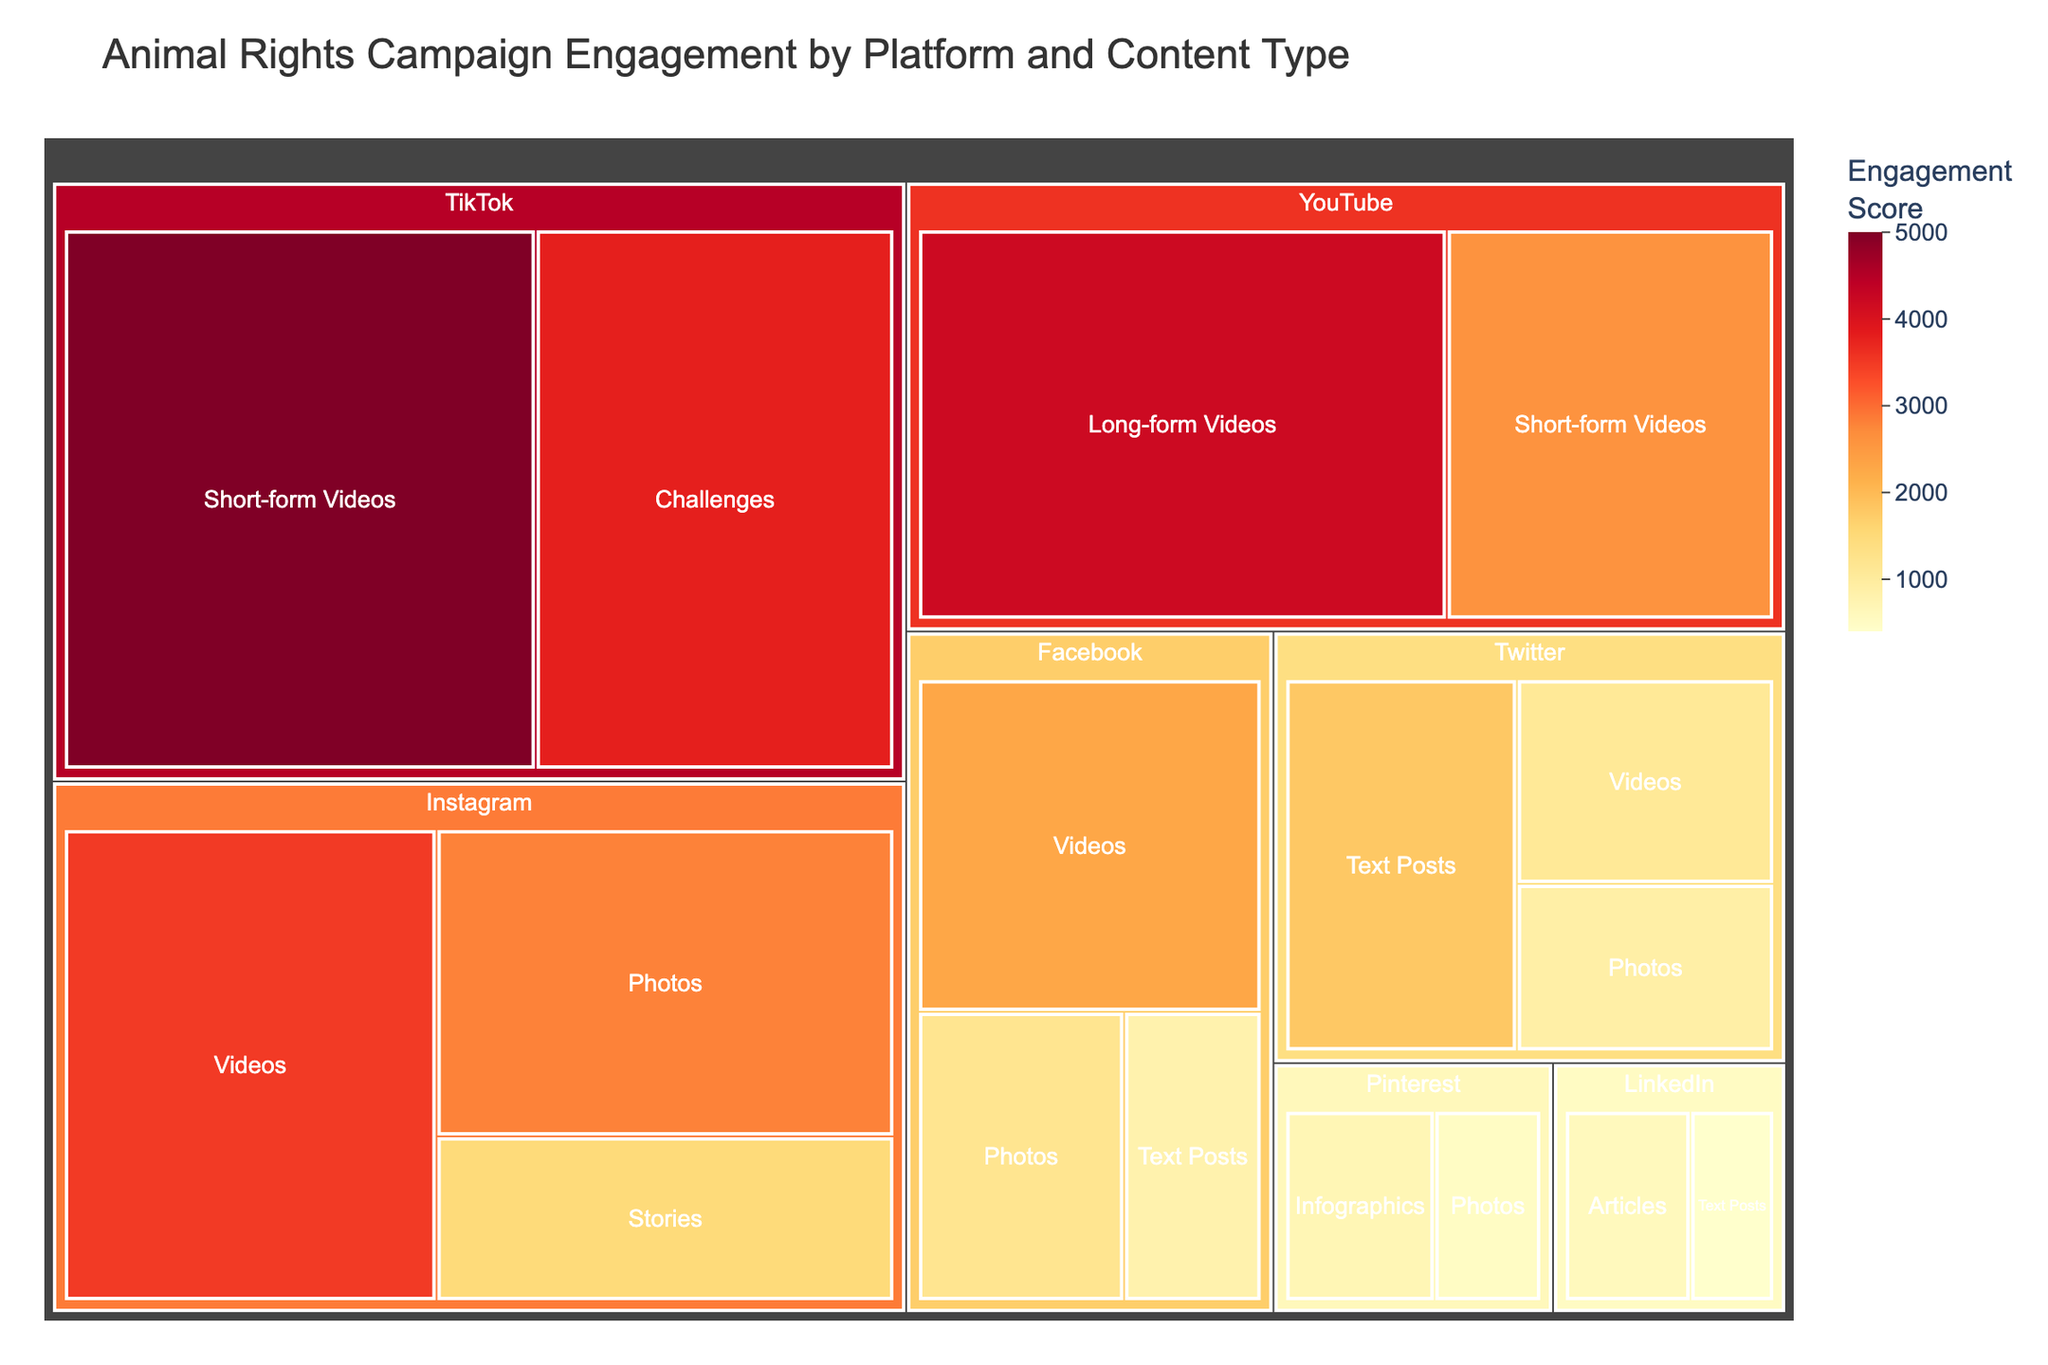What's the title of the figure? The title of the figure can be read directly at the top.
Answer: Animal Rights Campaign Engagement by Platform and Content Type Which platform has the highest engagement score? Look for the platform with the largest and darkest color block.
Answer: TikTok What's the engagement score for Instagram Stories? Find the "Instagram" section and look for the "Stories" block. The engagement score is written within it.
Answer: 1500 Compare the engagement scores between Facebook Photos and Facebook Videos. Which one has a higher score and by how much? Locate the Facebook section, then compare the scores of "Photos" and "Videos". Subtract the "Photos" score from the "Videos" score.
Answer: Facebook Videos have a higher score by 1100 What is the total engagement score for all content types on Twitter? Locate the Twitter section and sum up the scores for all listed content types (Text Posts, Photos, Videos).
Answer: 4800 Which content type has the highest engagement score on YouTube? Look for the YouTube section and compare the engagement scores of the listed content types (Long-form Videos, Short-form Videos).
Answer: Long-form Videos What is the difference in engagement score between TikTok Short-form Videos and YouTube Short-form Videos? Locate the TikTok and YouTube sections, find the scores for "Short-form Videos", and calculate the difference.
Answer: 2400 Is there any content type on LinkedIn that has an engagement score higher than 1000? Locate the LinkedIn section and check the scores of the listed content types (Articles, Text Posts).
Answer: No What's the engagement score sum for all Platforms combined? Sum the engagement scores of all listed content types across all platforms. This step involves addition across multiple sections.
Answer: 37400 Which platform has the least diverse content types in the figure? Identify the section with the least number of different content blocks.
Answer: LinkedIn 